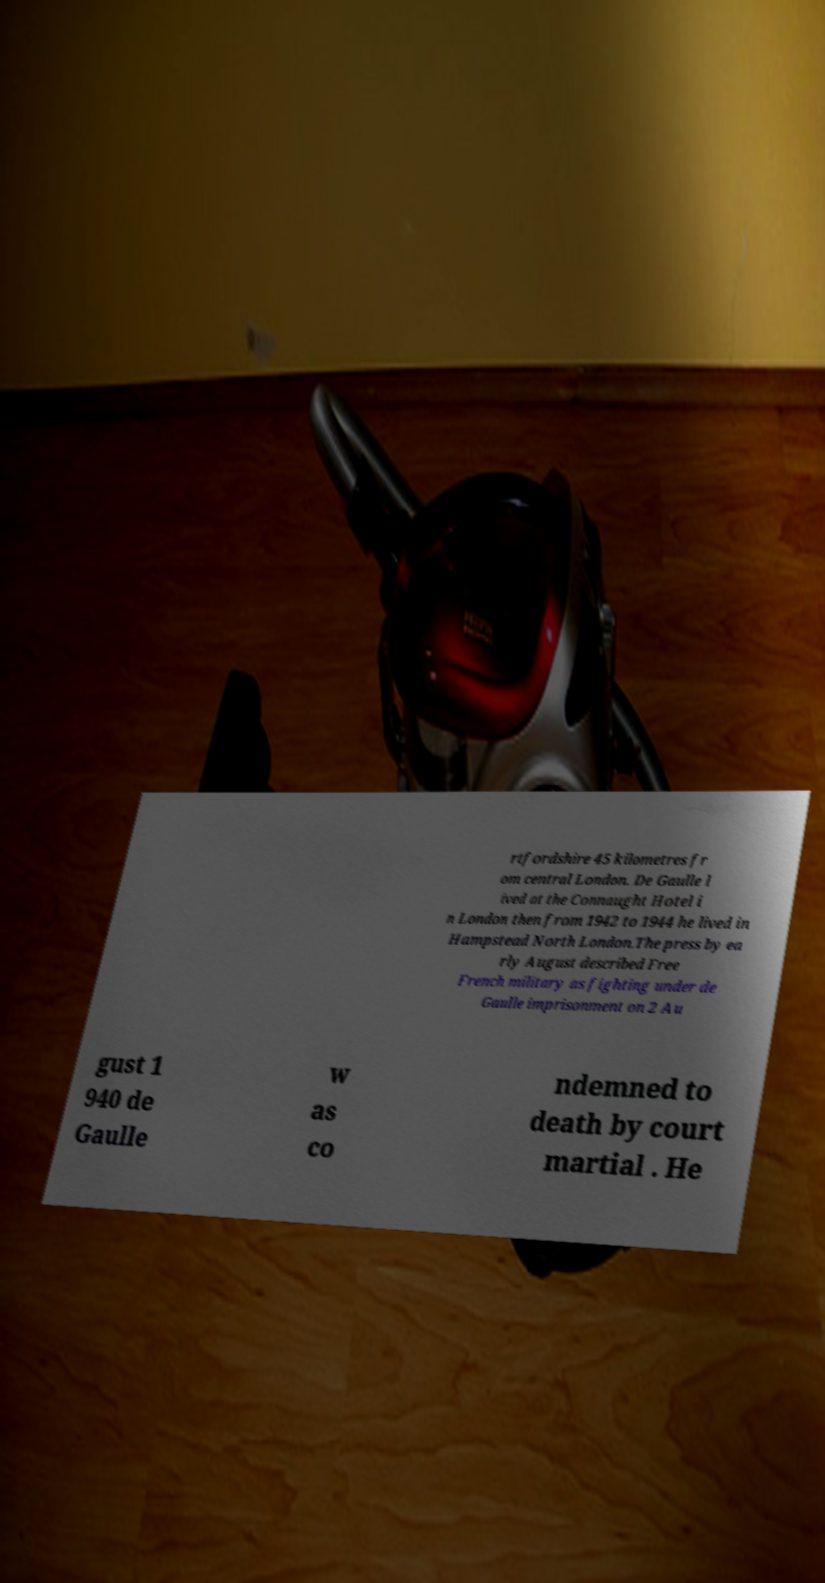Please read and relay the text visible in this image. What does it say? rtfordshire 45 kilometres fr om central London. De Gaulle l ived at the Connaught Hotel i n London then from 1942 to 1944 he lived in Hampstead North London.The press by ea rly August described Free French military as fighting under de Gaulle imprisonment on 2 Au gust 1 940 de Gaulle w as co ndemned to death by court martial . He 